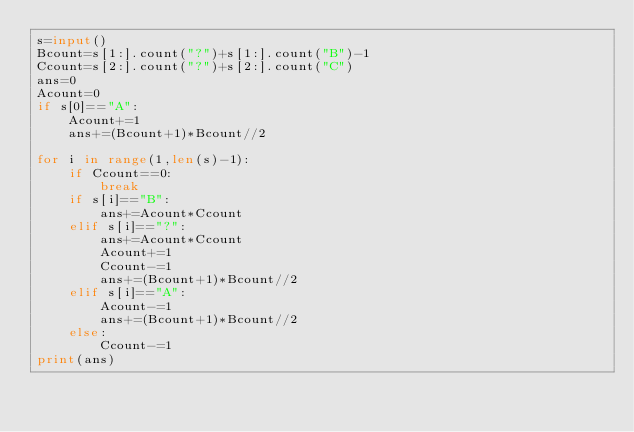<code> <loc_0><loc_0><loc_500><loc_500><_Python_>s=input()
Bcount=s[1:].count("?")+s[1:].count("B")-1
Ccount=s[2:].count("?")+s[2:].count("C")
ans=0
Acount=0
if s[0]=="A":
    Acount+=1
    ans+=(Bcount+1)*Bcount//2

for i in range(1,len(s)-1):
    if Ccount==0:
        break
    if s[i]=="B":
        ans+=Acount*Ccount
    elif s[i]=="?":
        ans+=Acount*Ccount
        Acount+=1
        Ccount-=1
        ans+=(Bcount+1)*Bcount//2
    elif s[i]=="A":
        Acount-=1
        ans+=(Bcount+1)*Bcount//2
    else:
        Ccount-=1
print(ans)
        </code> 